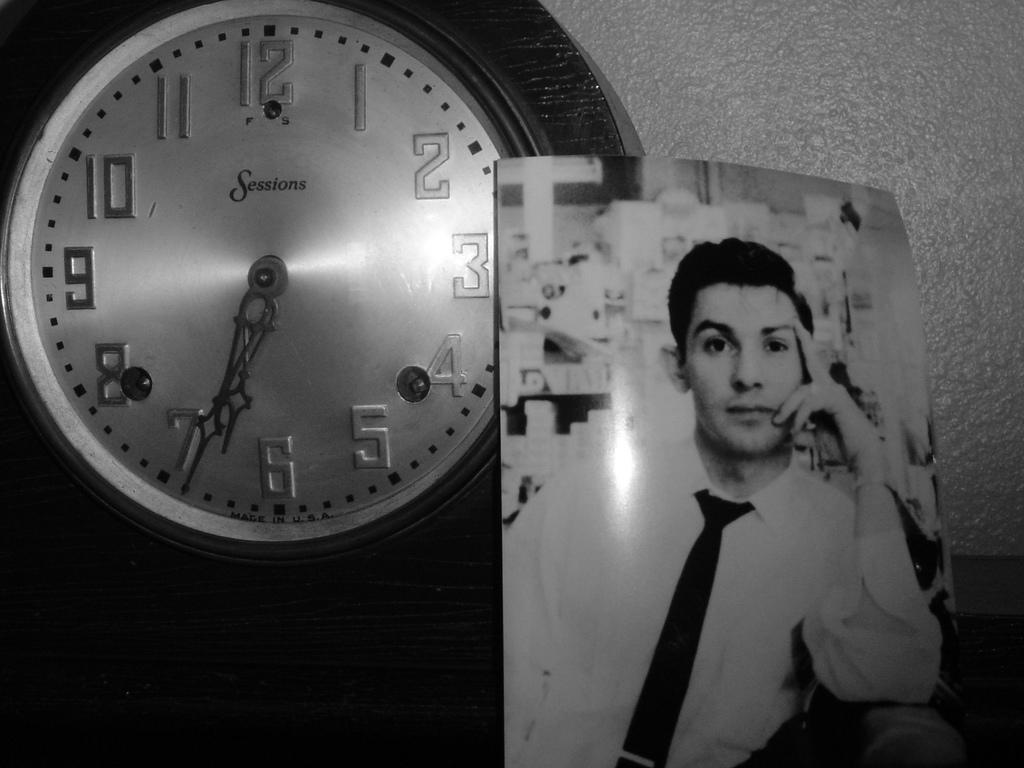<image>
Give a short and clear explanation of the subsequent image. A clock is next to a portrait and it says Sessions on the clock face. 